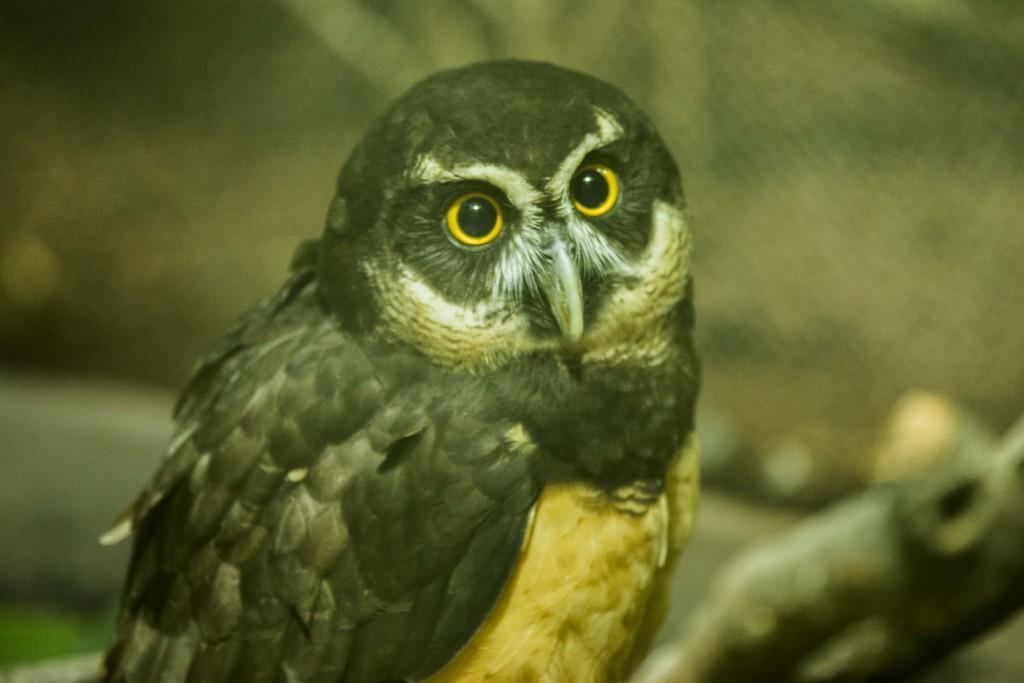Describe this image in one or two sentences. In this picture we can observe an owl. The eyes of this owl were in yellow and black color. In the background it is completely blur. 